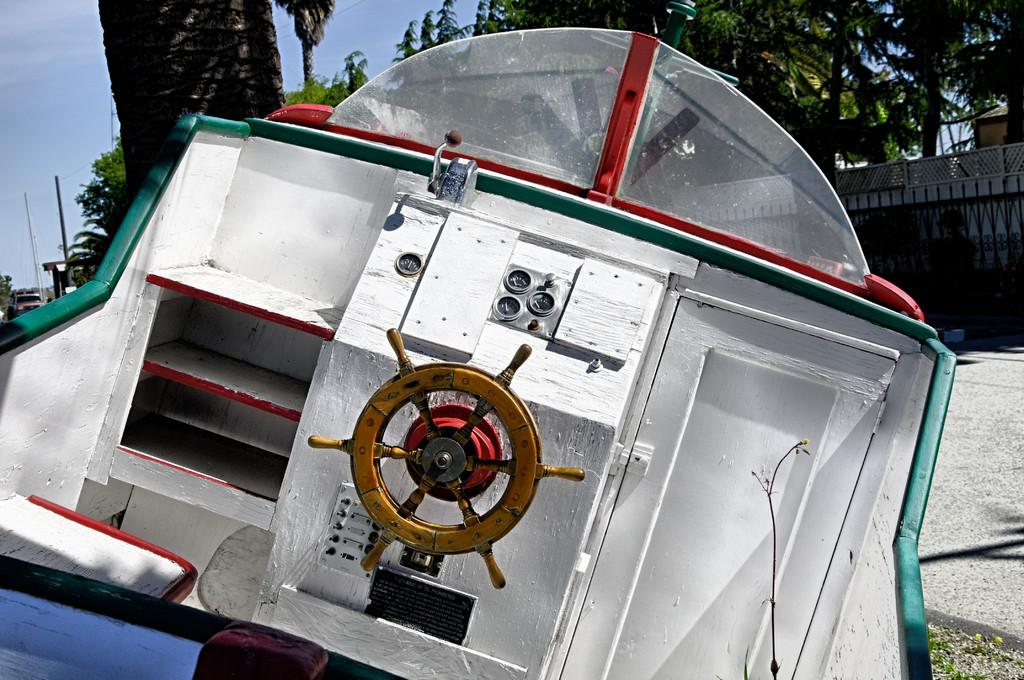What color is the boat in the image? The boat in the image is white. What can be used to steer the boat? There is a yellow color steering in the image. What type of barrier surrounds the area in the image? There is a black color fencing boundary wall in the image. What type of vegetation can be seen in the image? There are trees visible in the image. Where is the coat stored in the image? There is no coat present in the image. What type of sack is being used to transport goods in the image? There is no sack present in the image. 